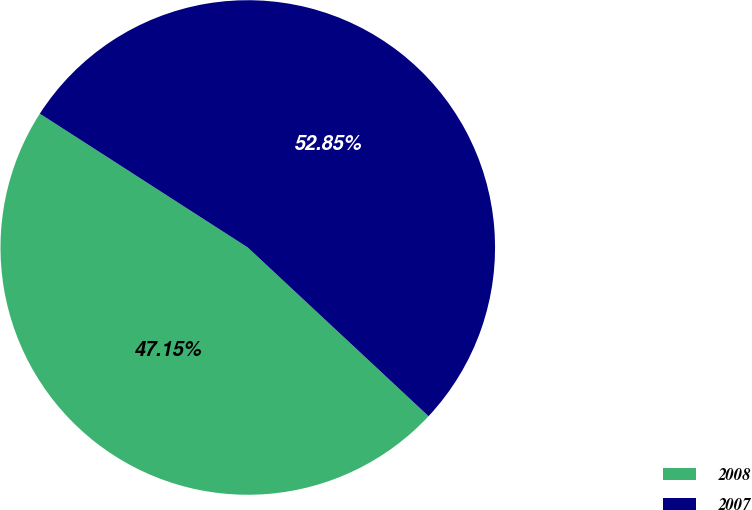Convert chart. <chart><loc_0><loc_0><loc_500><loc_500><pie_chart><fcel>2008<fcel>2007<nl><fcel>47.15%<fcel>52.85%<nl></chart> 